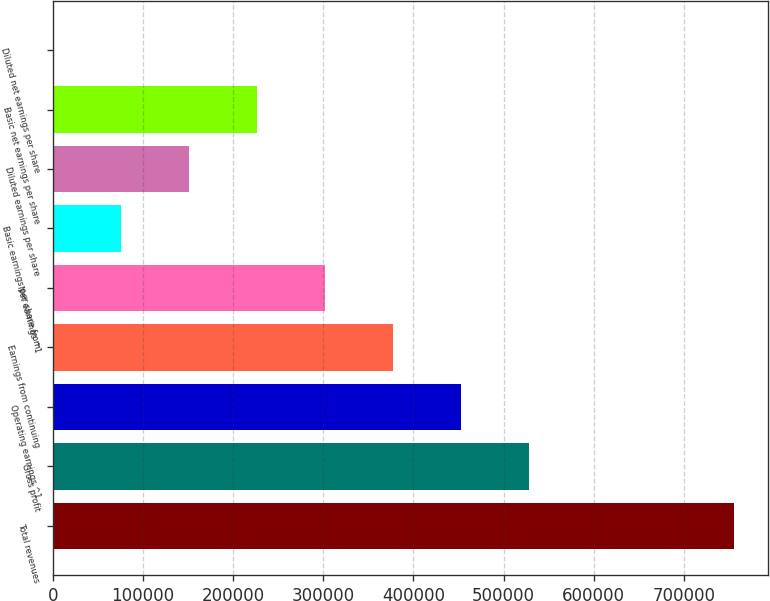Convert chart to OTSL. <chart><loc_0><loc_0><loc_500><loc_500><bar_chart><fcel>Total revenues<fcel>Gross profit<fcel>Operating earnings ^1<fcel>Earnings from continuing<fcel>Net earnings ^1<fcel>Basic earnings per share from<fcel>Diluted earnings per share<fcel>Basic net earnings per share<fcel>Diluted net earnings per share<nl><fcel>755027<fcel>528519<fcel>453016<fcel>377514<fcel>302011<fcel>75502.9<fcel>151006<fcel>226508<fcel>0.28<nl></chart> 